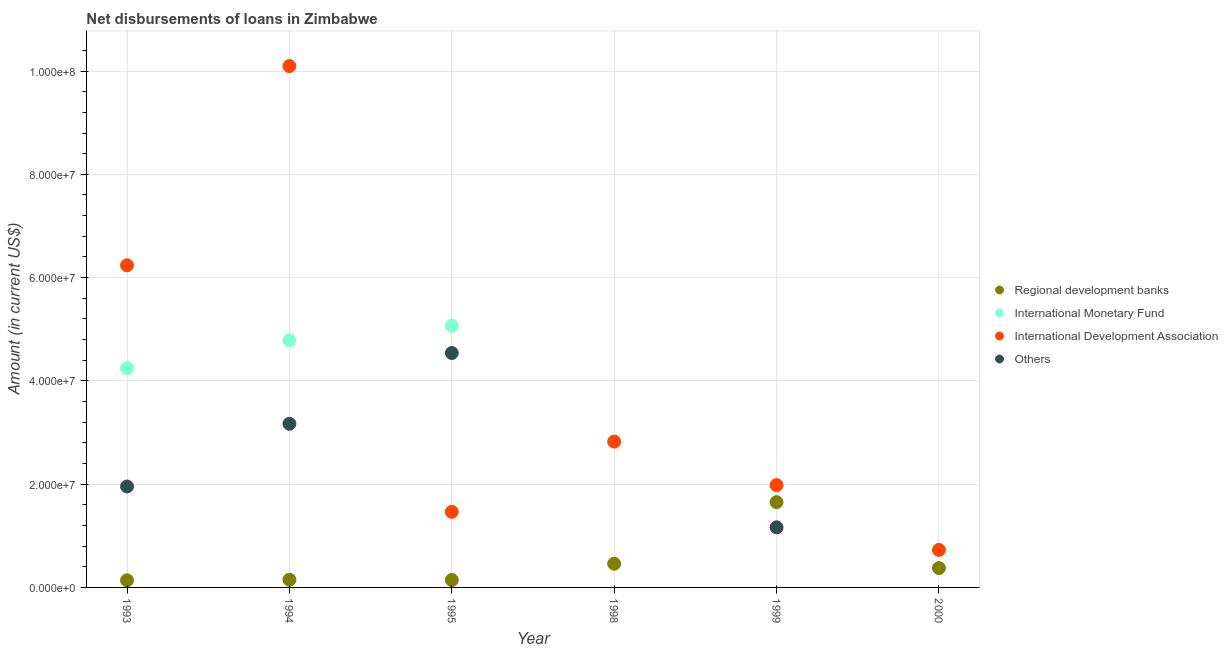Is the number of dotlines equal to the number of legend labels?
Your answer should be compact. No. What is the amount of loan disimbursed by other organisations in 1995?
Provide a succinct answer. 4.54e+07. Across all years, what is the maximum amount of loan disimbursed by international development association?
Ensure brevity in your answer.  1.01e+08. Across all years, what is the minimum amount of loan disimbursed by international monetary fund?
Make the answer very short. 0. What is the total amount of loan disimbursed by international development association in the graph?
Make the answer very short. 2.33e+08. What is the difference between the amount of loan disimbursed by international development association in 1994 and that in 1999?
Your answer should be very brief. 8.11e+07. What is the difference between the amount of loan disimbursed by international monetary fund in 1994 and the amount of loan disimbursed by regional development banks in 1993?
Give a very brief answer. 4.65e+07. What is the average amount of loan disimbursed by other organisations per year?
Your answer should be very brief. 1.80e+07. In the year 1994, what is the difference between the amount of loan disimbursed by international development association and amount of loan disimbursed by regional development banks?
Offer a very short reply. 9.95e+07. What is the ratio of the amount of loan disimbursed by other organisations in 1993 to that in 1995?
Provide a succinct answer. 0.43. Is the amount of loan disimbursed by regional development banks in 1995 less than that in 1999?
Keep it short and to the point. Yes. What is the difference between the highest and the second highest amount of loan disimbursed by international monetary fund?
Provide a succinct answer. 2.84e+06. What is the difference between the highest and the lowest amount of loan disimbursed by other organisations?
Give a very brief answer. 4.54e+07. Is it the case that in every year, the sum of the amount of loan disimbursed by other organisations and amount of loan disimbursed by regional development banks is greater than the sum of amount of loan disimbursed by international development association and amount of loan disimbursed by international monetary fund?
Keep it short and to the point. No. Is it the case that in every year, the sum of the amount of loan disimbursed by regional development banks and amount of loan disimbursed by international monetary fund is greater than the amount of loan disimbursed by international development association?
Offer a very short reply. No. Does the amount of loan disimbursed by regional development banks monotonically increase over the years?
Your answer should be very brief. No. Is the amount of loan disimbursed by regional development banks strictly greater than the amount of loan disimbursed by other organisations over the years?
Keep it short and to the point. No. Is the amount of loan disimbursed by other organisations strictly less than the amount of loan disimbursed by regional development banks over the years?
Make the answer very short. No. How many dotlines are there?
Your answer should be compact. 4. How many years are there in the graph?
Provide a succinct answer. 6. What is the difference between two consecutive major ticks on the Y-axis?
Give a very brief answer. 2.00e+07. Are the values on the major ticks of Y-axis written in scientific E-notation?
Provide a short and direct response. Yes. Does the graph contain any zero values?
Make the answer very short. Yes. How many legend labels are there?
Offer a terse response. 4. How are the legend labels stacked?
Provide a succinct answer. Vertical. What is the title of the graph?
Offer a terse response. Net disbursements of loans in Zimbabwe. What is the label or title of the X-axis?
Offer a very short reply. Year. What is the label or title of the Y-axis?
Your response must be concise. Amount (in current US$). What is the Amount (in current US$) in Regional development banks in 1993?
Your answer should be compact. 1.37e+06. What is the Amount (in current US$) in International Monetary Fund in 1993?
Keep it short and to the point. 4.24e+07. What is the Amount (in current US$) in International Development Association in 1993?
Give a very brief answer. 6.24e+07. What is the Amount (in current US$) of Others in 1993?
Make the answer very short. 1.95e+07. What is the Amount (in current US$) of Regional development banks in 1994?
Make the answer very short. 1.50e+06. What is the Amount (in current US$) in International Monetary Fund in 1994?
Give a very brief answer. 4.78e+07. What is the Amount (in current US$) in International Development Association in 1994?
Provide a short and direct response. 1.01e+08. What is the Amount (in current US$) of Others in 1994?
Give a very brief answer. 3.17e+07. What is the Amount (in current US$) in Regional development banks in 1995?
Keep it short and to the point. 1.43e+06. What is the Amount (in current US$) in International Monetary Fund in 1995?
Keep it short and to the point. 5.07e+07. What is the Amount (in current US$) of International Development Association in 1995?
Make the answer very short. 1.46e+07. What is the Amount (in current US$) in Others in 1995?
Your answer should be compact. 4.54e+07. What is the Amount (in current US$) of Regional development banks in 1998?
Offer a terse response. 4.59e+06. What is the Amount (in current US$) of International Development Association in 1998?
Your answer should be compact. 2.82e+07. What is the Amount (in current US$) of Others in 1998?
Give a very brief answer. 0. What is the Amount (in current US$) in Regional development banks in 1999?
Your response must be concise. 1.65e+07. What is the Amount (in current US$) in International Development Association in 1999?
Your answer should be compact. 1.98e+07. What is the Amount (in current US$) of Others in 1999?
Make the answer very short. 1.16e+07. What is the Amount (in current US$) of Regional development banks in 2000?
Offer a terse response. 3.75e+06. What is the Amount (in current US$) in International Development Association in 2000?
Offer a terse response. 7.26e+06. Across all years, what is the maximum Amount (in current US$) of Regional development banks?
Keep it short and to the point. 1.65e+07. Across all years, what is the maximum Amount (in current US$) in International Monetary Fund?
Give a very brief answer. 5.07e+07. Across all years, what is the maximum Amount (in current US$) in International Development Association?
Keep it short and to the point. 1.01e+08. Across all years, what is the maximum Amount (in current US$) of Others?
Provide a succinct answer. 4.54e+07. Across all years, what is the minimum Amount (in current US$) of Regional development banks?
Offer a very short reply. 1.37e+06. Across all years, what is the minimum Amount (in current US$) of International Monetary Fund?
Ensure brevity in your answer.  0. Across all years, what is the minimum Amount (in current US$) in International Development Association?
Keep it short and to the point. 7.26e+06. Across all years, what is the minimum Amount (in current US$) of Others?
Keep it short and to the point. 0. What is the total Amount (in current US$) in Regional development banks in the graph?
Provide a short and direct response. 2.92e+07. What is the total Amount (in current US$) in International Monetary Fund in the graph?
Ensure brevity in your answer.  1.41e+08. What is the total Amount (in current US$) of International Development Association in the graph?
Keep it short and to the point. 2.33e+08. What is the total Amount (in current US$) in Others in the graph?
Provide a short and direct response. 1.08e+08. What is the difference between the Amount (in current US$) in Regional development banks in 1993 and that in 1994?
Provide a short and direct response. -1.27e+05. What is the difference between the Amount (in current US$) in International Monetary Fund in 1993 and that in 1994?
Your answer should be compact. -5.38e+06. What is the difference between the Amount (in current US$) of International Development Association in 1993 and that in 1994?
Provide a short and direct response. -3.86e+07. What is the difference between the Amount (in current US$) in Others in 1993 and that in 1994?
Give a very brief answer. -1.21e+07. What is the difference between the Amount (in current US$) of Regional development banks in 1993 and that in 1995?
Offer a very short reply. -6.50e+04. What is the difference between the Amount (in current US$) in International Monetary Fund in 1993 and that in 1995?
Your answer should be very brief. -8.23e+06. What is the difference between the Amount (in current US$) in International Development Association in 1993 and that in 1995?
Provide a succinct answer. 4.77e+07. What is the difference between the Amount (in current US$) in Others in 1993 and that in 1995?
Ensure brevity in your answer.  -2.58e+07. What is the difference between the Amount (in current US$) of Regional development banks in 1993 and that in 1998?
Offer a very short reply. -3.22e+06. What is the difference between the Amount (in current US$) of International Development Association in 1993 and that in 1998?
Offer a terse response. 3.41e+07. What is the difference between the Amount (in current US$) of Regional development banks in 1993 and that in 1999?
Provide a succinct answer. -1.51e+07. What is the difference between the Amount (in current US$) in International Development Association in 1993 and that in 1999?
Keep it short and to the point. 4.26e+07. What is the difference between the Amount (in current US$) in Others in 1993 and that in 1999?
Your response must be concise. 7.91e+06. What is the difference between the Amount (in current US$) of Regional development banks in 1993 and that in 2000?
Your answer should be compact. -2.38e+06. What is the difference between the Amount (in current US$) in International Development Association in 1993 and that in 2000?
Give a very brief answer. 5.51e+07. What is the difference between the Amount (in current US$) in Regional development banks in 1994 and that in 1995?
Make the answer very short. 6.20e+04. What is the difference between the Amount (in current US$) of International Monetary Fund in 1994 and that in 1995?
Your response must be concise. -2.84e+06. What is the difference between the Amount (in current US$) of International Development Association in 1994 and that in 1995?
Make the answer very short. 8.63e+07. What is the difference between the Amount (in current US$) of Others in 1994 and that in 1995?
Your answer should be very brief. -1.37e+07. What is the difference between the Amount (in current US$) of Regional development banks in 1994 and that in 1998?
Your answer should be very brief. -3.09e+06. What is the difference between the Amount (in current US$) of International Development Association in 1994 and that in 1998?
Offer a very short reply. 7.27e+07. What is the difference between the Amount (in current US$) of Regional development banks in 1994 and that in 1999?
Your response must be concise. -1.50e+07. What is the difference between the Amount (in current US$) in International Development Association in 1994 and that in 1999?
Provide a succinct answer. 8.11e+07. What is the difference between the Amount (in current US$) in Others in 1994 and that in 1999?
Your answer should be compact. 2.01e+07. What is the difference between the Amount (in current US$) of Regional development banks in 1994 and that in 2000?
Ensure brevity in your answer.  -2.25e+06. What is the difference between the Amount (in current US$) in International Development Association in 1994 and that in 2000?
Make the answer very short. 9.37e+07. What is the difference between the Amount (in current US$) of Regional development banks in 1995 and that in 1998?
Provide a succinct answer. -3.16e+06. What is the difference between the Amount (in current US$) in International Development Association in 1995 and that in 1998?
Offer a terse response. -1.36e+07. What is the difference between the Amount (in current US$) of Regional development banks in 1995 and that in 1999?
Provide a succinct answer. -1.51e+07. What is the difference between the Amount (in current US$) of International Development Association in 1995 and that in 1999?
Give a very brief answer. -5.17e+06. What is the difference between the Amount (in current US$) in Others in 1995 and that in 1999?
Keep it short and to the point. 3.38e+07. What is the difference between the Amount (in current US$) of Regional development banks in 1995 and that in 2000?
Offer a very short reply. -2.31e+06. What is the difference between the Amount (in current US$) of International Development Association in 1995 and that in 2000?
Make the answer very short. 7.38e+06. What is the difference between the Amount (in current US$) of Regional development banks in 1998 and that in 1999?
Offer a very short reply. -1.19e+07. What is the difference between the Amount (in current US$) of International Development Association in 1998 and that in 1999?
Keep it short and to the point. 8.42e+06. What is the difference between the Amount (in current US$) of Regional development banks in 1998 and that in 2000?
Ensure brevity in your answer.  8.43e+05. What is the difference between the Amount (in current US$) in International Development Association in 1998 and that in 2000?
Give a very brief answer. 2.10e+07. What is the difference between the Amount (in current US$) of Regional development banks in 1999 and that in 2000?
Provide a succinct answer. 1.28e+07. What is the difference between the Amount (in current US$) in International Development Association in 1999 and that in 2000?
Give a very brief answer. 1.25e+07. What is the difference between the Amount (in current US$) in Regional development banks in 1993 and the Amount (in current US$) in International Monetary Fund in 1994?
Give a very brief answer. -4.65e+07. What is the difference between the Amount (in current US$) of Regional development banks in 1993 and the Amount (in current US$) of International Development Association in 1994?
Offer a very short reply. -9.96e+07. What is the difference between the Amount (in current US$) of Regional development banks in 1993 and the Amount (in current US$) of Others in 1994?
Ensure brevity in your answer.  -3.03e+07. What is the difference between the Amount (in current US$) in International Monetary Fund in 1993 and the Amount (in current US$) in International Development Association in 1994?
Provide a succinct answer. -5.85e+07. What is the difference between the Amount (in current US$) in International Monetary Fund in 1993 and the Amount (in current US$) in Others in 1994?
Your answer should be very brief. 1.08e+07. What is the difference between the Amount (in current US$) in International Development Association in 1993 and the Amount (in current US$) in Others in 1994?
Your answer should be very brief. 3.07e+07. What is the difference between the Amount (in current US$) of Regional development banks in 1993 and the Amount (in current US$) of International Monetary Fund in 1995?
Offer a very short reply. -4.93e+07. What is the difference between the Amount (in current US$) in Regional development banks in 1993 and the Amount (in current US$) in International Development Association in 1995?
Make the answer very short. -1.33e+07. What is the difference between the Amount (in current US$) in Regional development banks in 1993 and the Amount (in current US$) in Others in 1995?
Provide a succinct answer. -4.40e+07. What is the difference between the Amount (in current US$) of International Monetary Fund in 1993 and the Amount (in current US$) of International Development Association in 1995?
Make the answer very short. 2.78e+07. What is the difference between the Amount (in current US$) of International Monetary Fund in 1993 and the Amount (in current US$) of Others in 1995?
Your response must be concise. -2.94e+06. What is the difference between the Amount (in current US$) in International Development Association in 1993 and the Amount (in current US$) in Others in 1995?
Offer a very short reply. 1.70e+07. What is the difference between the Amount (in current US$) in Regional development banks in 1993 and the Amount (in current US$) in International Development Association in 1998?
Ensure brevity in your answer.  -2.69e+07. What is the difference between the Amount (in current US$) in International Monetary Fund in 1993 and the Amount (in current US$) in International Development Association in 1998?
Offer a very short reply. 1.42e+07. What is the difference between the Amount (in current US$) of Regional development banks in 1993 and the Amount (in current US$) of International Development Association in 1999?
Make the answer very short. -1.84e+07. What is the difference between the Amount (in current US$) in Regional development banks in 1993 and the Amount (in current US$) in Others in 1999?
Keep it short and to the point. -1.03e+07. What is the difference between the Amount (in current US$) of International Monetary Fund in 1993 and the Amount (in current US$) of International Development Association in 1999?
Offer a very short reply. 2.26e+07. What is the difference between the Amount (in current US$) of International Monetary Fund in 1993 and the Amount (in current US$) of Others in 1999?
Provide a short and direct response. 3.08e+07. What is the difference between the Amount (in current US$) in International Development Association in 1993 and the Amount (in current US$) in Others in 1999?
Give a very brief answer. 5.07e+07. What is the difference between the Amount (in current US$) in Regional development banks in 1993 and the Amount (in current US$) in International Development Association in 2000?
Your response must be concise. -5.89e+06. What is the difference between the Amount (in current US$) in International Monetary Fund in 1993 and the Amount (in current US$) in International Development Association in 2000?
Your answer should be compact. 3.52e+07. What is the difference between the Amount (in current US$) in Regional development banks in 1994 and the Amount (in current US$) in International Monetary Fund in 1995?
Give a very brief answer. -4.92e+07. What is the difference between the Amount (in current US$) in Regional development banks in 1994 and the Amount (in current US$) in International Development Association in 1995?
Provide a short and direct response. -1.31e+07. What is the difference between the Amount (in current US$) of Regional development banks in 1994 and the Amount (in current US$) of Others in 1995?
Your response must be concise. -4.39e+07. What is the difference between the Amount (in current US$) in International Monetary Fund in 1994 and the Amount (in current US$) in International Development Association in 1995?
Provide a short and direct response. 3.32e+07. What is the difference between the Amount (in current US$) in International Monetary Fund in 1994 and the Amount (in current US$) in Others in 1995?
Give a very brief answer. 2.44e+06. What is the difference between the Amount (in current US$) in International Development Association in 1994 and the Amount (in current US$) in Others in 1995?
Ensure brevity in your answer.  5.56e+07. What is the difference between the Amount (in current US$) in Regional development banks in 1994 and the Amount (in current US$) in International Development Association in 1998?
Provide a succinct answer. -2.67e+07. What is the difference between the Amount (in current US$) in International Monetary Fund in 1994 and the Amount (in current US$) in International Development Association in 1998?
Ensure brevity in your answer.  1.96e+07. What is the difference between the Amount (in current US$) in Regional development banks in 1994 and the Amount (in current US$) in International Development Association in 1999?
Provide a succinct answer. -1.83e+07. What is the difference between the Amount (in current US$) in Regional development banks in 1994 and the Amount (in current US$) in Others in 1999?
Ensure brevity in your answer.  -1.01e+07. What is the difference between the Amount (in current US$) in International Monetary Fund in 1994 and the Amount (in current US$) in International Development Association in 1999?
Make the answer very short. 2.80e+07. What is the difference between the Amount (in current US$) in International Monetary Fund in 1994 and the Amount (in current US$) in Others in 1999?
Your answer should be compact. 3.62e+07. What is the difference between the Amount (in current US$) of International Development Association in 1994 and the Amount (in current US$) of Others in 1999?
Offer a terse response. 8.93e+07. What is the difference between the Amount (in current US$) in Regional development banks in 1994 and the Amount (in current US$) in International Development Association in 2000?
Provide a succinct answer. -5.76e+06. What is the difference between the Amount (in current US$) in International Monetary Fund in 1994 and the Amount (in current US$) in International Development Association in 2000?
Make the answer very short. 4.06e+07. What is the difference between the Amount (in current US$) of Regional development banks in 1995 and the Amount (in current US$) of International Development Association in 1998?
Offer a terse response. -2.68e+07. What is the difference between the Amount (in current US$) in International Monetary Fund in 1995 and the Amount (in current US$) in International Development Association in 1998?
Your response must be concise. 2.24e+07. What is the difference between the Amount (in current US$) in Regional development banks in 1995 and the Amount (in current US$) in International Development Association in 1999?
Offer a terse response. -1.84e+07. What is the difference between the Amount (in current US$) of Regional development banks in 1995 and the Amount (in current US$) of Others in 1999?
Make the answer very short. -1.02e+07. What is the difference between the Amount (in current US$) of International Monetary Fund in 1995 and the Amount (in current US$) of International Development Association in 1999?
Offer a very short reply. 3.09e+07. What is the difference between the Amount (in current US$) in International Monetary Fund in 1995 and the Amount (in current US$) in Others in 1999?
Give a very brief answer. 3.90e+07. What is the difference between the Amount (in current US$) of International Development Association in 1995 and the Amount (in current US$) of Others in 1999?
Offer a terse response. 3.00e+06. What is the difference between the Amount (in current US$) of Regional development banks in 1995 and the Amount (in current US$) of International Development Association in 2000?
Provide a succinct answer. -5.83e+06. What is the difference between the Amount (in current US$) in International Monetary Fund in 1995 and the Amount (in current US$) in International Development Association in 2000?
Your answer should be very brief. 4.34e+07. What is the difference between the Amount (in current US$) of Regional development banks in 1998 and the Amount (in current US$) of International Development Association in 1999?
Keep it short and to the point. -1.52e+07. What is the difference between the Amount (in current US$) in Regional development banks in 1998 and the Amount (in current US$) in Others in 1999?
Your answer should be compact. -7.05e+06. What is the difference between the Amount (in current US$) of International Development Association in 1998 and the Amount (in current US$) of Others in 1999?
Offer a terse response. 1.66e+07. What is the difference between the Amount (in current US$) of Regional development banks in 1998 and the Amount (in current US$) of International Development Association in 2000?
Give a very brief answer. -2.67e+06. What is the difference between the Amount (in current US$) in Regional development banks in 1999 and the Amount (in current US$) in International Development Association in 2000?
Provide a succinct answer. 9.25e+06. What is the average Amount (in current US$) in Regional development banks per year?
Make the answer very short. 4.86e+06. What is the average Amount (in current US$) in International Monetary Fund per year?
Make the answer very short. 2.35e+07. What is the average Amount (in current US$) of International Development Association per year?
Offer a terse response. 3.89e+07. What is the average Amount (in current US$) in Others per year?
Make the answer very short. 1.80e+07. In the year 1993, what is the difference between the Amount (in current US$) in Regional development banks and Amount (in current US$) in International Monetary Fund?
Your answer should be very brief. -4.11e+07. In the year 1993, what is the difference between the Amount (in current US$) in Regional development banks and Amount (in current US$) in International Development Association?
Offer a terse response. -6.10e+07. In the year 1993, what is the difference between the Amount (in current US$) in Regional development banks and Amount (in current US$) in Others?
Offer a terse response. -1.82e+07. In the year 1993, what is the difference between the Amount (in current US$) of International Monetary Fund and Amount (in current US$) of International Development Association?
Your response must be concise. -1.99e+07. In the year 1993, what is the difference between the Amount (in current US$) of International Monetary Fund and Amount (in current US$) of Others?
Keep it short and to the point. 2.29e+07. In the year 1993, what is the difference between the Amount (in current US$) of International Development Association and Amount (in current US$) of Others?
Offer a terse response. 4.28e+07. In the year 1994, what is the difference between the Amount (in current US$) of Regional development banks and Amount (in current US$) of International Monetary Fund?
Provide a succinct answer. -4.63e+07. In the year 1994, what is the difference between the Amount (in current US$) in Regional development banks and Amount (in current US$) in International Development Association?
Your response must be concise. -9.95e+07. In the year 1994, what is the difference between the Amount (in current US$) in Regional development banks and Amount (in current US$) in Others?
Offer a very short reply. -3.02e+07. In the year 1994, what is the difference between the Amount (in current US$) of International Monetary Fund and Amount (in current US$) of International Development Association?
Ensure brevity in your answer.  -5.31e+07. In the year 1994, what is the difference between the Amount (in current US$) of International Monetary Fund and Amount (in current US$) of Others?
Keep it short and to the point. 1.61e+07. In the year 1994, what is the difference between the Amount (in current US$) of International Development Association and Amount (in current US$) of Others?
Keep it short and to the point. 6.93e+07. In the year 1995, what is the difference between the Amount (in current US$) of Regional development banks and Amount (in current US$) of International Monetary Fund?
Keep it short and to the point. -4.92e+07. In the year 1995, what is the difference between the Amount (in current US$) in Regional development banks and Amount (in current US$) in International Development Association?
Offer a very short reply. -1.32e+07. In the year 1995, what is the difference between the Amount (in current US$) of Regional development banks and Amount (in current US$) of Others?
Provide a short and direct response. -4.40e+07. In the year 1995, what is the difference between the Amount (in current US$) in International Monetary Fund and Amount (in current US$) in International Development Association?
Provide a short and direct response. 3.60e+07. In the year 1995, what is the difference between the Amount (in current US$) of International Monetary Fund and Amount (in current US$) of Others?
Your answer should be compact. 5.28e+06. In the year 1995, what is the difference between the Amount (in current US$) in International Development Association and Amount (in current US$) in Others?
Provide a short and direct response. -3.08e+07. In the year 1998, what is the difference between the Amount (in current US$) in Regional development banks and Amount (in current US$) in International Development Association?
Offer a terse response. -2.36e+07. In the year 1999, what is the difference between the Amount (in current US$) of Regional development banks and Amount (in current US$) of International Development Association?
Your answer should be compact. -3.29e+06. In the year 1999, what is the difference between the Amount (in current US$) of Regional development banks and Amount (in current US$) of Others?
Offer a terse response. 4.88e+06. In the year 1999, what is the difference between the Amount (in current US$) in International Development Association and Amount (in current US$) in Others?
Your response must be concise. 8.17e+06. In the year 2000, what is the difference between the Amount (in current US$) of Regional development banks and Amount (in current US$) of International Development Association?
Provide a succinct answer. -3.51e+06. What is the ratio of the Amount (in current US$) of Regional development banks in 1993 to that in 1994?
Your answer should be very brief. 0.92. What is the ratio of the Amount (in current US$) of International Monetary Fund in 1993 to that in 1994?
Keep it short and to the point. 0.89. What is the ratio of the Amount (in current US$) in International Development Association in 1993 to that in 1994?
Provide a short and direct response. 0.62. What is the ratio of the Amount (in current US$) in Others in 1993 to that in 1994?
Give a very brief answer. 0.62. What is the ratio of the Amount (in current US$) in Regional development banks in 1993 to that in 1995?
Keep it short and to the point. 0.95. What is the ratio of the Amount (in current US$) of International Monetary Fund in 1993 to that in 1995?
Your answer should be very brief. 0.84. What is the ratio of the Amount (in current US$) of International Development Association in 1993 to that in 1995?
Your answer should be compact. 4.26. What is the ratio of the Amount (in current US$) in Others in 1993 to that in 1995?
Provide a succinct answer. 0.43. What is the ratio of the Amount (in current US$) in Regional development banks in 1993 to that in 1998?
Make the answer very short. 0.3. What is the ratio of the Amount (in current US$) in International Development Association in 1993 to that in 1998?
Provide a short and direct response. 2.21. What is the ratio of the Amount (in current US$) in Regional development banks in 1993 to that in 1999?
Your answer should be compact. 0.08. What is the ratio of the Amount (in current US$) of International Development Association in 1993 to that in 1999?
Keep it short and to the point. 3.15. What is the ratio of the Amount (in current US$) in Others in 1993 to that in 1999?
Offer a terse response. 1.68. What is the ratio of the Amount (in current US$) in Regional development banks in 1993 to that in 2000?
Give a very brief answer. 0.37. What is the ratio of the Amount (in current US$) in International Development Association in 1993 to that in 2000?
Provide a succinct answer. 8.59. What is the ratio of the Amount (in current US$) in Regional development banks in 1994 to that in 1995?
Ensure brevity in your answer.  1.04. What is the ratio of the Amount (in current US$) in International Monetary Fund in 1994 to that in 1995?
Your response must be concise. 0.94. What is the ratio of the Amount (in current US$) in International Development Association in 1994 to that in 1995?
Ensure brevity in your answer.  6.9. What is the ratio of the Amount (in current US$) in Others in 1994 to that in 1995?
Your response must be concise. 0.7. What is the ratio of the Amount (in current US$) in Regional development banks in 1994 to that in 1998?
Give a very brief answer. 0.33. What is the ratio of the Amount (in current US$) of International Development Association in 1994 to that in 1998?
Keep it short and to the point. 3.58. What is the ratio of the Amount (in current US$) in Regional development banks in 1994 to that in 1999?
Your response must be concise. 0.09. What is the ratio of the Amount (in current US$) of International Development Association in 1994 to that in 1999?
Your response must be concise. 5.1. What is the ratio of the Amount (in current US$) in Others in 1994 to that in 1999?
Offer a terse response. 2.72. What is the ratio of the Amount (in current US$) in Regional development banks in 1994 to that in 2000?
Your answer should be compact. 0.4. What is the ratio of the Amount (in current US$) of International Development Association in 1994 to that in 2000?
Give a very brief answer. 13.9. What is the ratio of the Amount (in current US$) in Regional development banks in 1995 to that in 1998?
Provide a succinct answer. 0.31. What is the ratio of the Amount (in current US$) in International Development Association in 1995 to that in 1998?
Your answer should be compact. 0.52. What is the ratio of the Amount (in current US$) in Regional development banks in 1995 to that in 1999?
Your answer should be very brief. 0.09. What is the ratio of the Amount (in current US$) of International Development Association in 1995 to that in 1999?
Make the answer very short. 0.74. What is the ratio of the Amount (in current US$) in Others in 1995 to that in 1999?
Keep it short and to the point. 3.9. What is the ratio of the Amount (in current US$) in Regional development banks in 1995 to that in 2000?
Your response must be concise. 0.38. What is the ratio of the Amount (in current US$) of International Development Association in 1995 to that in 2000?
Offer a very short reply. 2.02. What is the ratio of the Amount (in current US$) of Regional development banks in 1998 to that in 1999?
Give a very brief answer. 0.28. What is the ratio of the Amount (in current US$) in International Development Association in 1998 to that in 1999?
Your answer should be compact. 1.43. What is the ratio of the Amount (in current US$) in Regional development banks in 1998 to that in 2000?
Keep it short and to the point. 1.23. What is the ratio of the Amount (in current US$) of International Development Association in 1998 to that in 2000?
Give a very brief answer. 3.89. What is the ratio of the Amount (in current US$) in Regional development banks in 1999 to that in 2000?
Offer a terse response. 4.41. What is the ratio of the Amount (in current US$) in International Development Association in 1999 to that in 2000?
Ensure brevity in your answer.  2.73. What is the difference between the highest and the second highest Amount (in current US$) in Regional development banks?
Ensure brevity in your answer.  1.19e+07. What is the difference between the highest and the second highest Amount (in current US$) in International Monetary Fund?
Give a very brief answer. 2.84e+06. What is the difference between the highest and the second highest Amount (in current US$) of International Development Association?
Make the answer very short. 3.86e+07. What is the difference between the highest and the second highest Amount (in current US$) in Others?
Provide a succinct answer. 1.37e+07. What is the difference between the highest and the lowest Amount (in current US$) in Regional development banks?
Give a very brief answer. 1.51e+07. What is the difference between the highest and the lowest Amount (in current US$) of International Monetary Fund?
Keep it short and to the point. 5.07e+07. What is the difference between the highest and the lowest Amount (in current US$) in International Development Association?
Your response must be concise. 9.37e+07. What is the difference between the highest and the lowest Amount (in current US$) in Others?
Ensure brevity in your answer.  4.54e+07. 